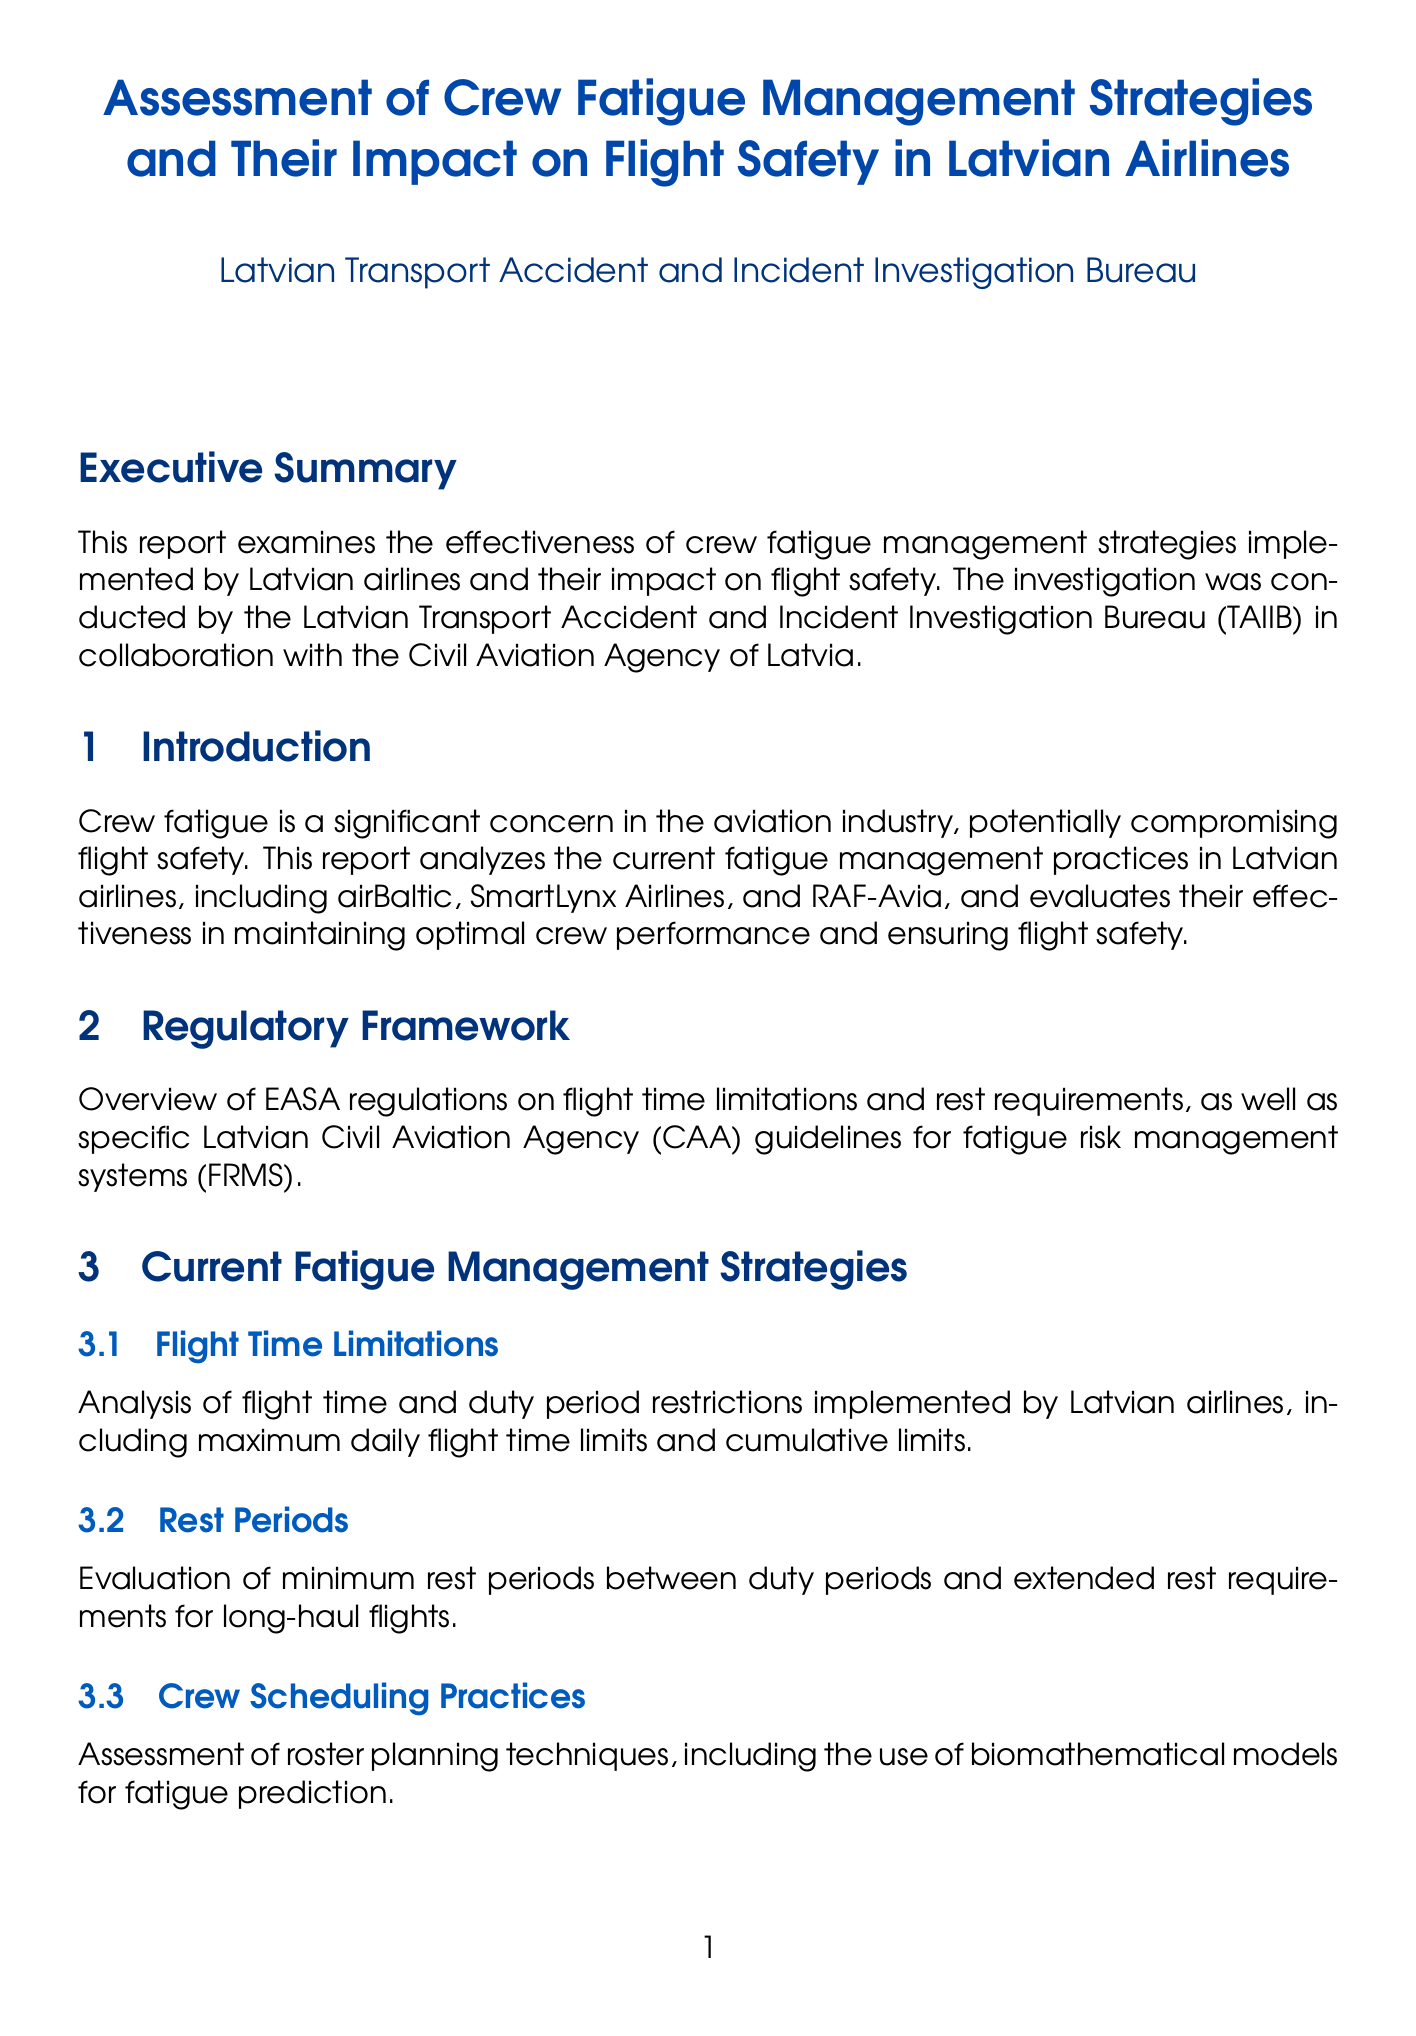What is the title of the report? The title of the report is the main heading provided at the beginning of the document.
Answer: Assessment of Crew Fatigue Management Strategies and Their Impact on Flight Safety in Latvian Airlines Who conducted the investigation? The investigation was conducted by the Latvian Transport Accident and Incident Investigation Bureau in collaboration with the Civil Aviation Agency of Latvia.
Answer: Latvian Transport Accident and Incident Investigation Bureau Which airlines are analyzed in the report? The report analyzes current fatigue management practices in specific Latvian airlines mentioned in the introduction section.
Answer: airBaltic, SmartLynx Airlines, RAF-Avia What year did the airBaltic incident occur? The year of the incident is specified in the corresponding subsection title in the case studies section.
Answer: 2019 What does FRMS stand for? FRMS is an acronym explained in the context of fatigue management strategies in the report's recommendations.
Answer: Fatigue Risk Management Systems What technology is recommended for fatigue monitoring? The specific technology recommended is mentioned in the recommendations subsection regarding fatigue monitoring.
Answer: Jeppesen CrewAlert app What type of analysis is conducted regarding flight safety? The type of analysis is specified in the title of the section discussing the impact on flight safety.
Answer: Statistical analysis How many flight crew members participated in the survey? The number of participants in the survey is detailed in the appendix about survey results.
Answer: 500 What is one recommendation for improving flight crew training? One of the proposals in the report focuses on specific aspects of training for flight crew members contained in the recommendations section.
Answer: Enhanced fatigue management training programs 